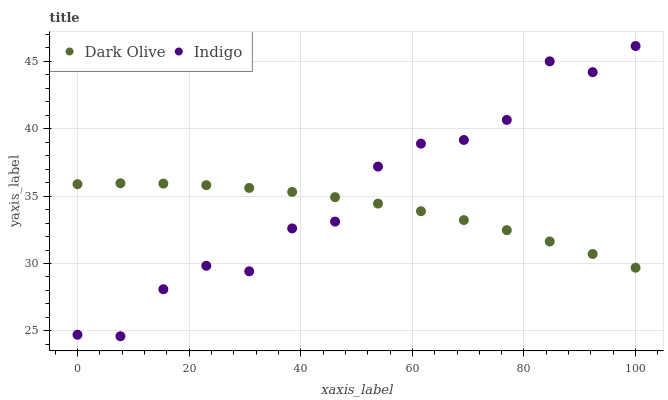Does Dark Olive have the minimum area under the curve?
Answer yes or no. Yes. Does Indigo have the maximum area under the curve?
Answer yes or no. Yes. Does Indigo have the minimum area under the curve?
Answer yes or no. No. Is Dark Olive the smoothest?
Answer yes or no. Yes. Is Indigo the roughest?
Answer yes or no. Yes. Is Indigo the smoothest?
Answer yes or no. No. Does Indigo have the lowest value?
Answer yes or no. Yes. Does Indigo have the highest value?
Answer yes or no. Yes. Does Indigo intersect Dark Olive?
Answer yes or no. Yes. Is Indigo less than Dark Olive?
Answer yes or no. No. Is Indigo greater than Dark Olive?
Answer yes or no. No. 